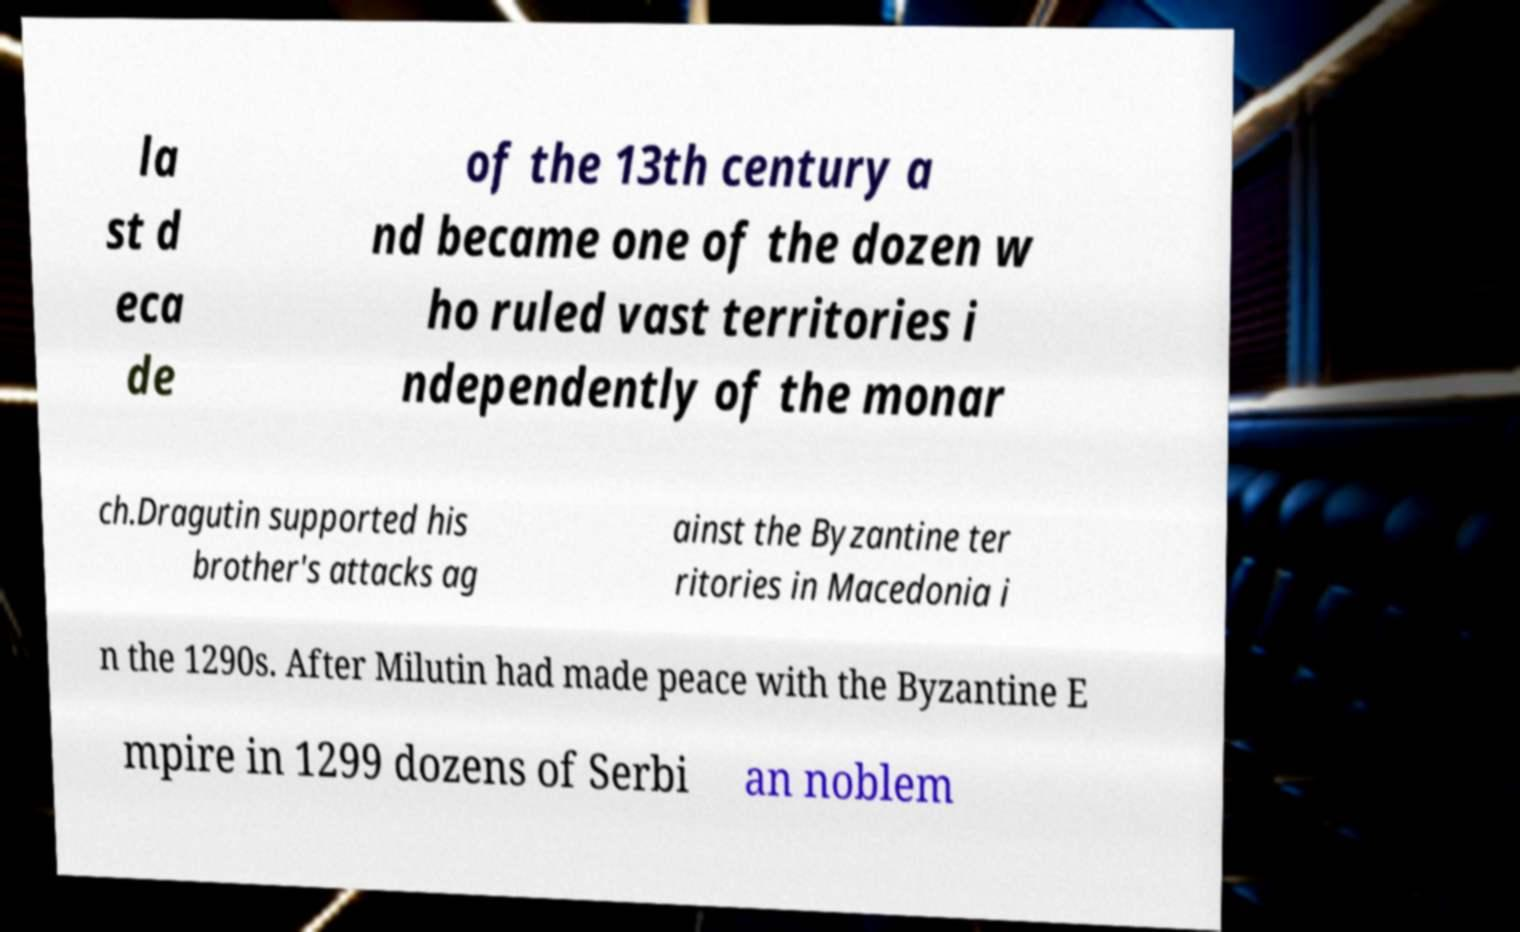Please identify and transcribe the text found in this image. la st d eca de of the 13th century a nd became one of the dozen w ho ruled vast territories i ndependently of the monar ch.Dragutin supported his brother's attacks ag ainst the Byzantine ter ritories in Macedonia i n the 1290s. After Milutin had made peace with the Byzantine E mpire in 1299 dozens of Serbi an noblem 